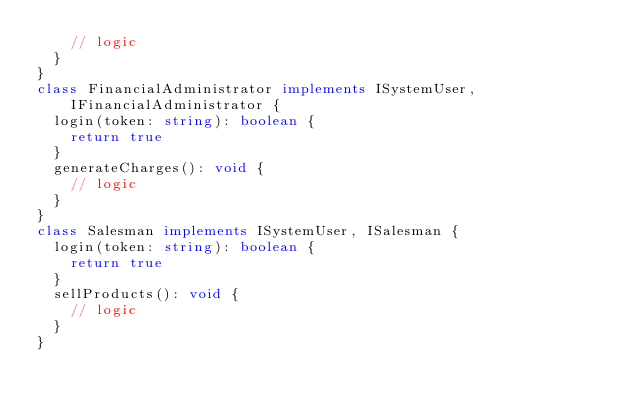Convert code to text. <code><loc_0><loc_0><loc_500><loc_500><_TypeScript_>    // logic
  }
}
class FinancialAdministrator implements ISystemUser, IFinancialAdministrator {
  login(token: string): boolean {
    return true
  }
  generateCharges(): void {
    // logic
  }
}
class Salesman implements ISystemUser, ISalesman {
  login(token: string): boolean {
    return true
  }
  sellProducts(): void {
    // logic
  }
}
</code> 